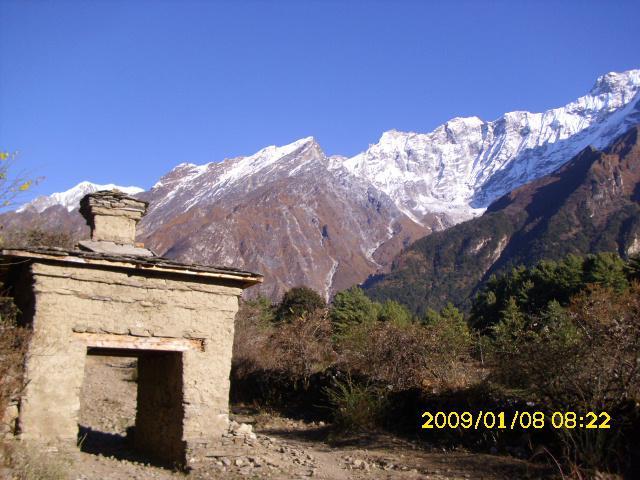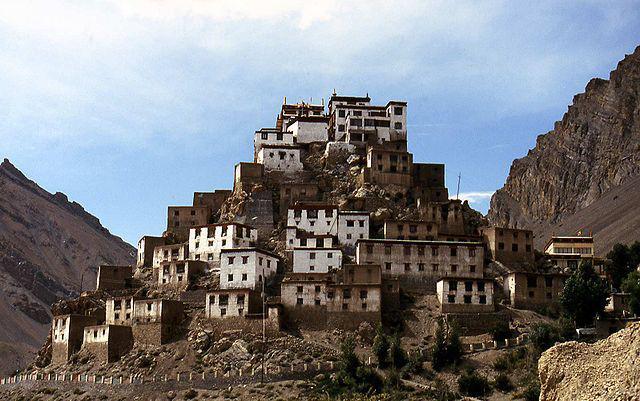The first image is the image on the left, the second image is the image on the right. Assess this claim about the two images: "There are flags located on several buildings in one of the images.". Correct or not? Answer yes or no. No. 